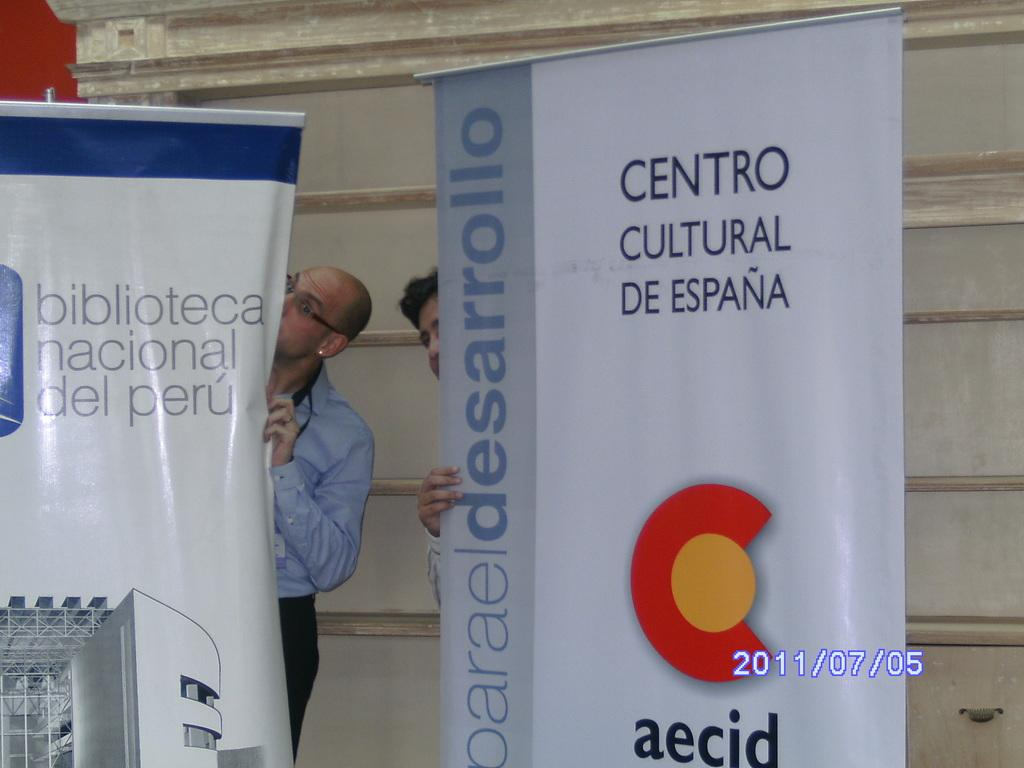<image>
Summarize the visual content of the image. A gray and white banner promotes Centro Cultural De Espana. 